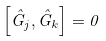Convert formula to latex. <formula><loc_0><loc_0><loc_500><loc_500>\left [ \hat { G } _ { j } , \hat { G } _ { k } \right ] = 0</formula> 